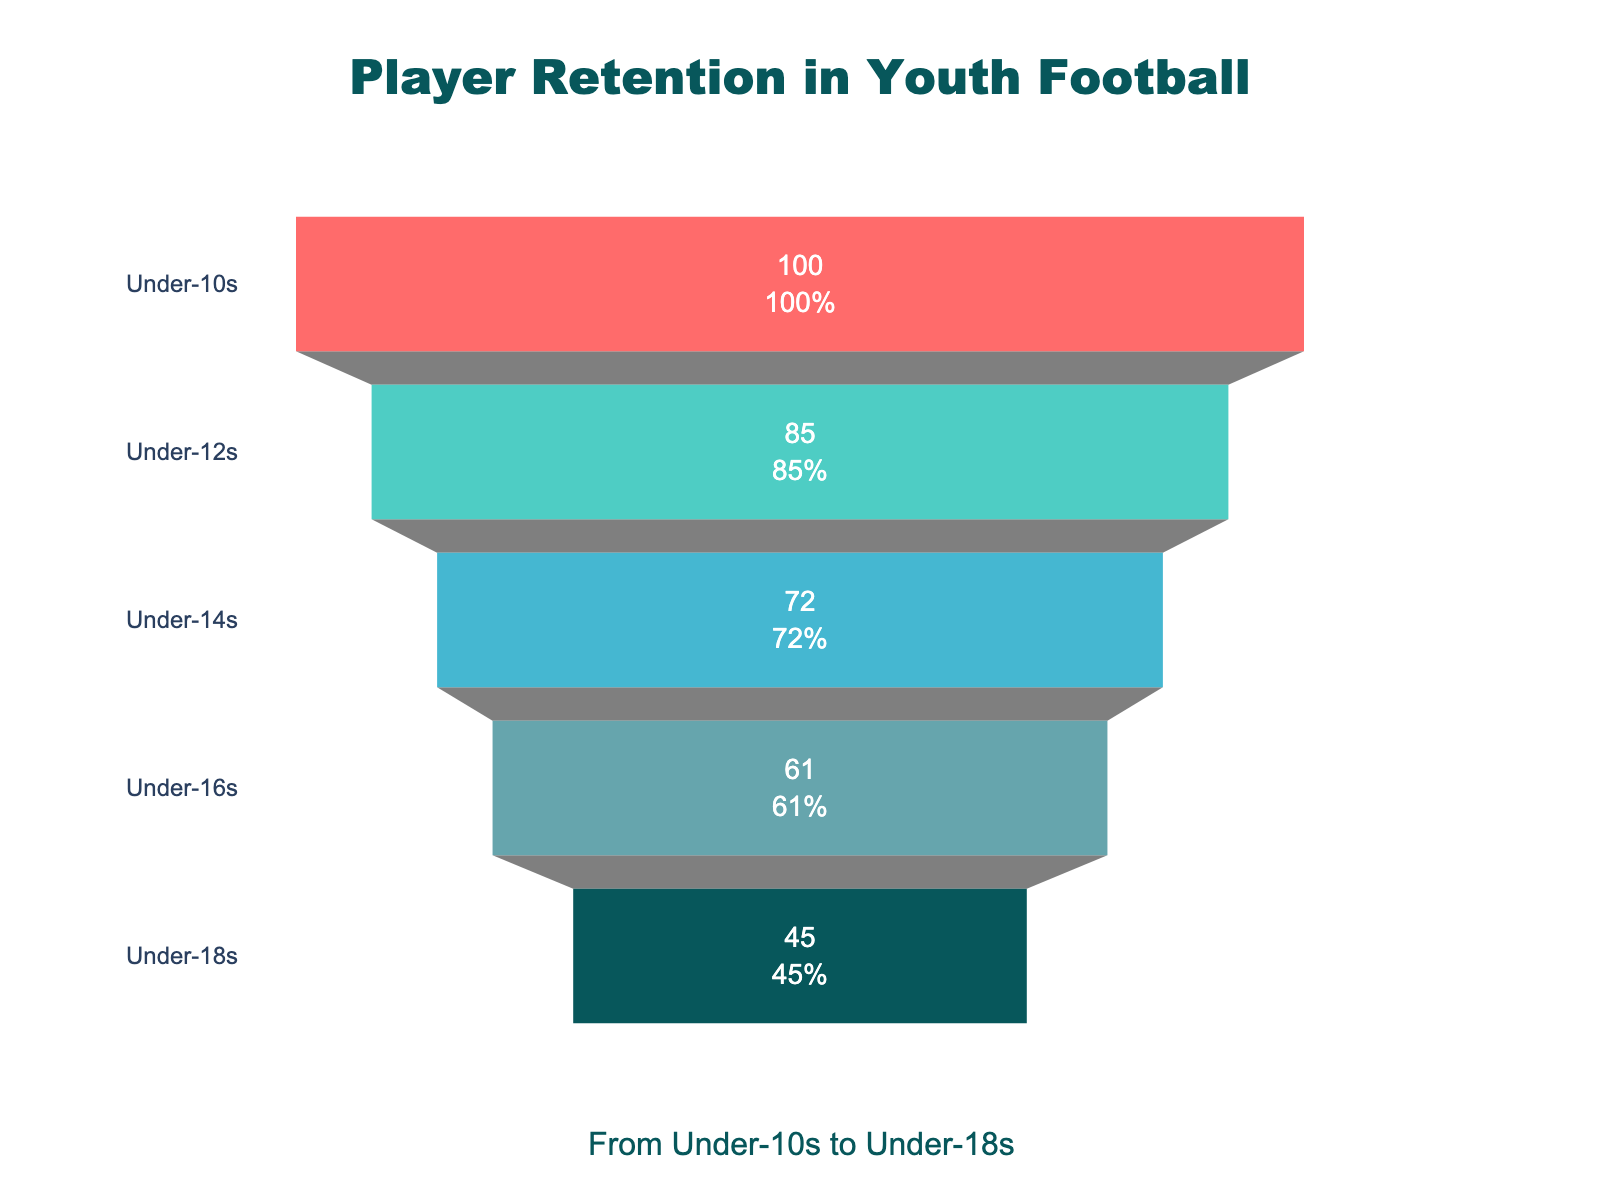What is the title of the funnel chart? The title is located at the top center of the chart, indicating the topic of focus. It reads "Player Retention in Youth Football," summarizing that the data shows retention rates from different age groups.
Answer: Player Retention in Youth Football How many age groups are displayed on the funnel chart? Each category of the funnel represents an age group. Counting the layers, we see there are five groups shown: Under-10s, Under-12s, Under-14s, Under-16s, and Under-18s.
Answer: 5 What is the color representing the Under-10s age group? The color of each age group's section in the funnel chart is distinct. The Under-10s age group is at the top and is represented by the brightest red color.
Answer: Red How many players were retained in the Under-16s age group? The value inside the funnel segment for Under-16s, which is the fourth layer from the top, shows the number of players retained in this group, which is 61.
Answer: 61 What percentage of the initial Under-10s players were retained in the Under-18s group? To find the percentage, divide the number of players retained in Under-18s (45) by those in Under-10s (100) and multiply by 100. The calculation is (45/100) * 100 = 45%.
Answer: 45% Which age group had the largest drop in player retention compared to the previous group? By comparing each successive group's numbers: Under-10s to Under-12s (100-85=15), Under-12s to Under-14s (85-72=13), Under-14s to Under-16s (72-61=11), Under-16s to Under-18s (61-45=16), the largest drop is from Under-16s to Under-18s with 16 players.
Answer: Under-16s to Under-18s What is the average number of players retained across all age groups? Sum the players retained in all age groups then divide by the number of groups: (100 + 85 + 72 + 61 + 45) / 5 = 363 / 5 = 72.6.
Answer: 72.6 How many more players were retained in the Under-14s than in the Under-18s? Subtract the number of players retained in the Under-18s from the Under-14s: 72 - 45 = 27.
Answer: 27 Identify the age group in the middle of the funnel chart. The funnel chart displays layers representing different age groups; the middle group is the one in the third position from the top, which is the Under-14s.
Answer: Under-14s What does the annotation at the bottom of the chart say? The annotation text located below the funnel chart reads "From Under-10s to Under-18s," providing context to the age range displayed.
Answer: From Under-10s to Under-18s 